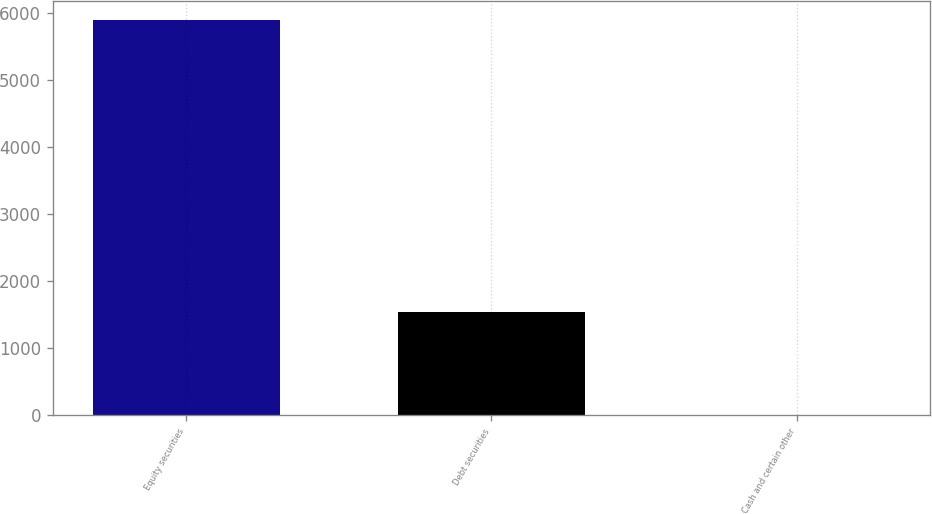Convert chart to OTSL. <chart><loc_0><loc_0><loc_500><loc_500><bar_chart><fcel>Equity securities<fcel>Debt securities<fcel>Cash and certain other<nl><fcel>5885<fcel>1542<fcel>5<nl></chart> 